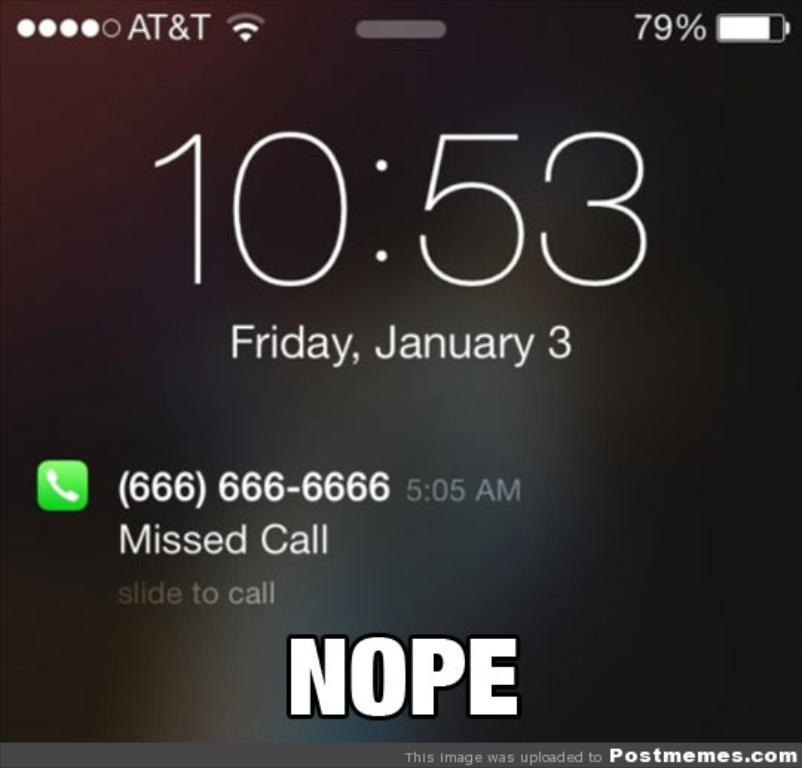<image>
Describe the image concisely. A phones lock screen that shows a missed call from a number 